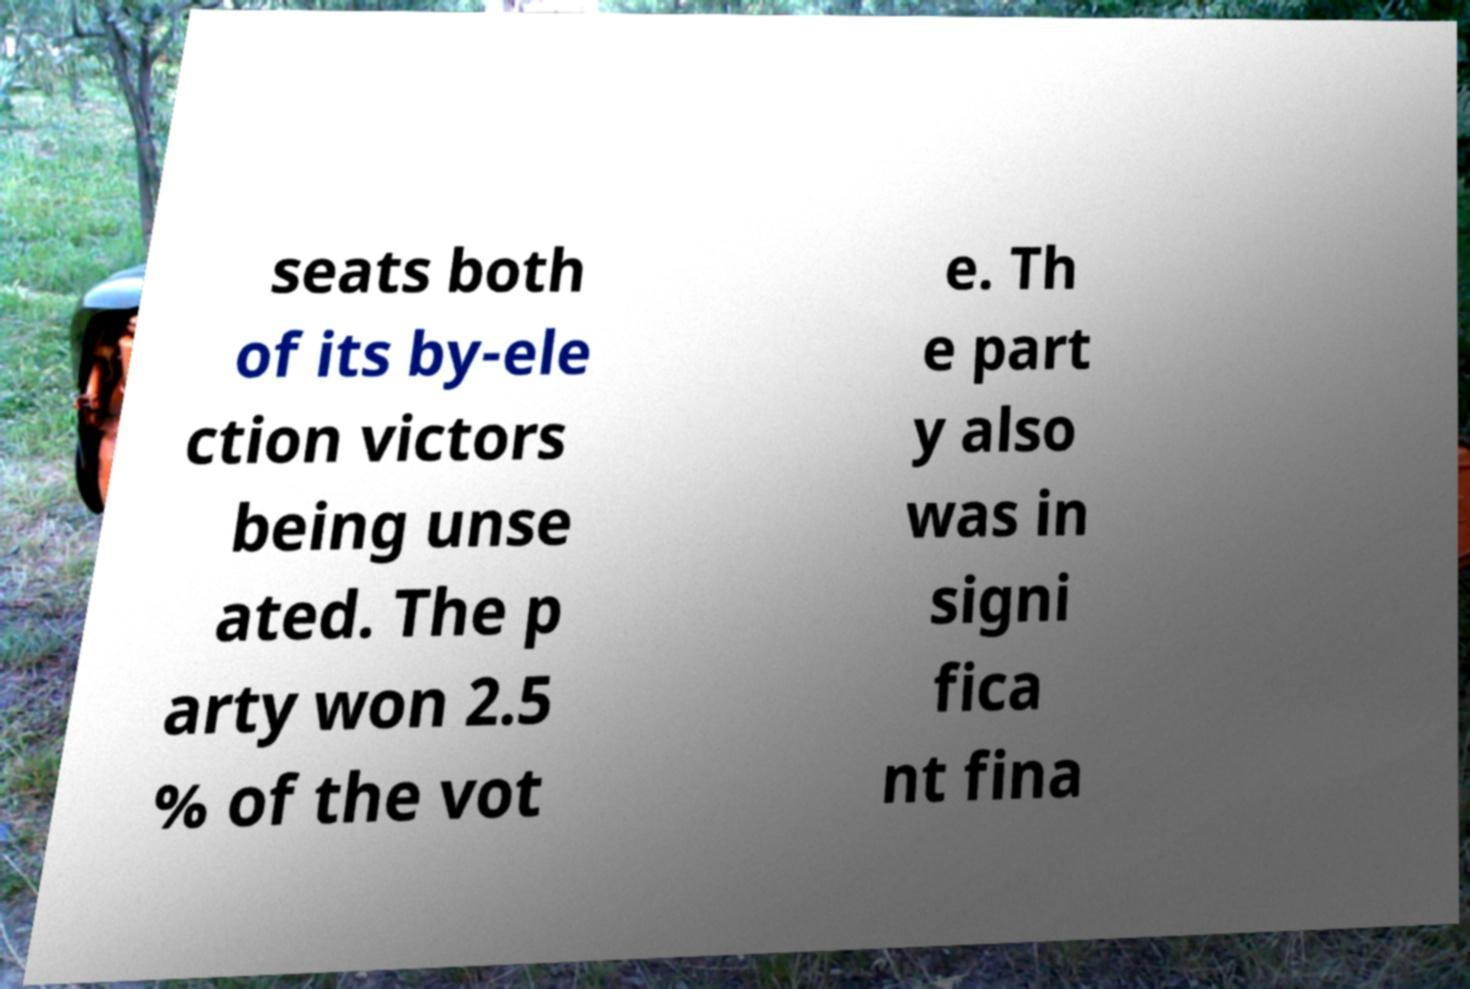Please read and relay the text visible in this image. What does it say? seats both of its by-ele ction victors being unse ated. The p arty won 2.5 % of the vot e. Th e part y also was in signi fica nt fina 